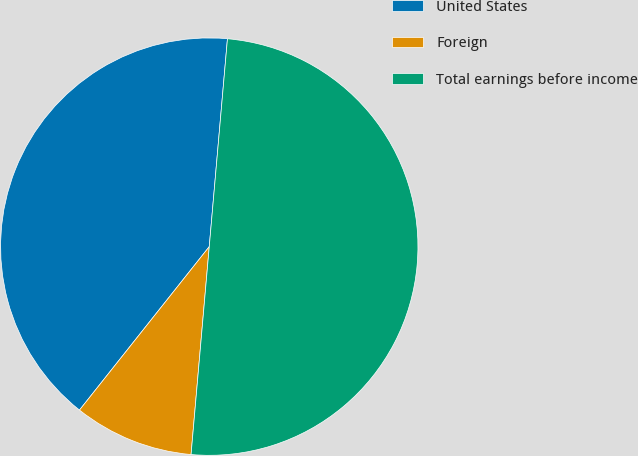<chart> <loc_0><loc_0><loc_500><loc_500><pie_chart><fcel>United States<fcel>Foreign<fcel>Total earnings before income<nl><fcel>40.71%<fcel>9.29%<fcel>50.0%<nl></chart> 